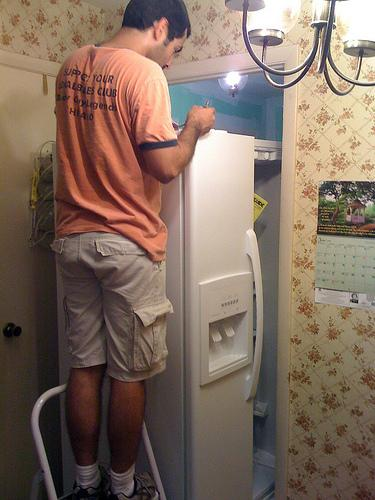Describe the wallpaper present in the image. There is beige floral wallpaper on the wall in the image. Detail the type of stool the man is standing on. The man is standing on a white metal step stool. Give a brief explanation of what hangs on the wall and what rests on the ceiling. A calendar is hanging on the wall, and a metal lamp is mounted on the ceiling. What type of shorts does the man wear, and mention the color. The man is wearing tan khaki cargo shorts. Write a sentence about one of the refrigerator's features and its location. The refrigerator door has an ice and water dispenser located in its door. What color shirt is the man wearing and what is he doing? The man is wearing an orange cotton tee shirt and is working on a white refrigerator that is stuck in the doorway. What can be seen on the side of the road in the image? There are multiple instances of a red and white bus on the side of the road in the image. Please kindly provide a short description of the refrigerator and its current situation. The white refrigerator has one door, is missing a door, and features an ice and water dispenser. It is currently stuck in the doorway. Can you explain the issue the man is trying to solve in the image? The man is attempting to remove the doors of the refrigerator to make it fit through the doorway. Identify the type of footwear and their color worn by the man in the picture. The man is wearing grey and blue sneakers. 